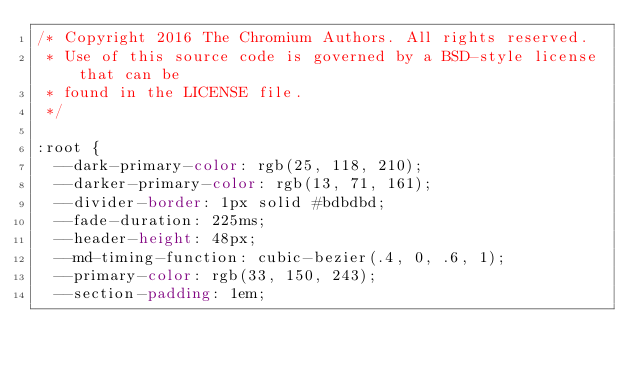<code> <loc_0><loc_0><loc_500><loc_500><_CSS_>/* Copyright 2016 The Chromium Authors. All rights reserved.
 * Use of this source code is governed by a BSD-style license that can be
 * found in the LICENSE file.
 */

:root {
  --dark-primary-color: rgb(25, 118, 210);
  --darker-primary-color: rgb(13, 71, 161);
  --divider-border: 1px solid #bdbdbd;
  --fade-duration: 225ms;
  --header-height: 48px;
  --md-timing-function: cubic-bezier(.4, 0, .6, 1);
  --primary-color: rgb(33, 150, 243);
  --section-padding: 1em;</code> 